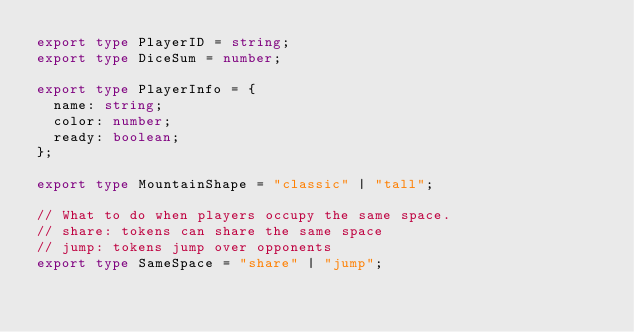<code> <loc_0><loc_0><loc_500><loc_500><_TypeScript_>export type PlayerID = string;
export type DiceSum = number;

export type PlayerInfo = {
  name: string;
  color: number;
  ready: boolean;
};

export type MountainShape = "classic" | "tall";

// What to do when players occupy the same space.
// share: tokens can share the same space
// jump: tokens jump over opponents
export type SameSpace = "share" | "jump";
</code> 